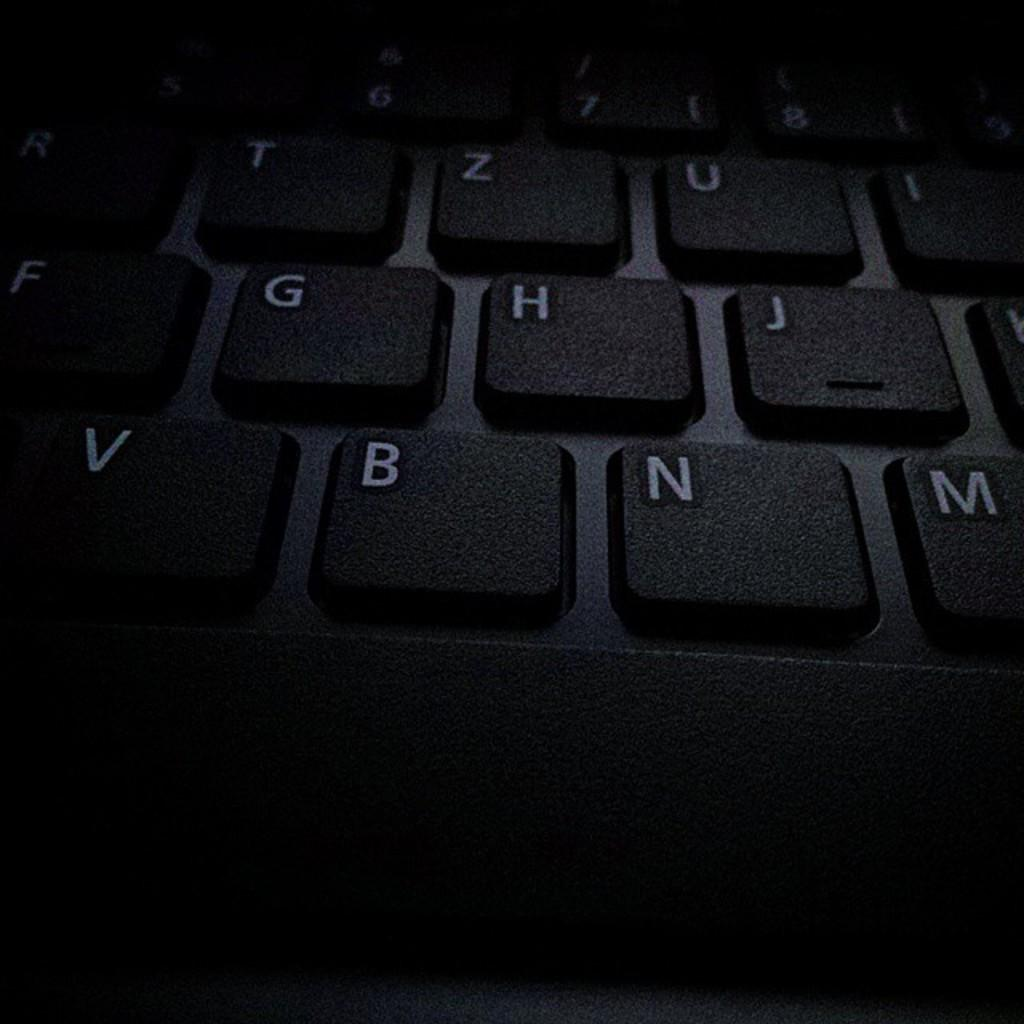<image>
Present a compact description of the photo's key features. A black keyboard with the letters Z,U, H,J,V,B,N,M visible. 